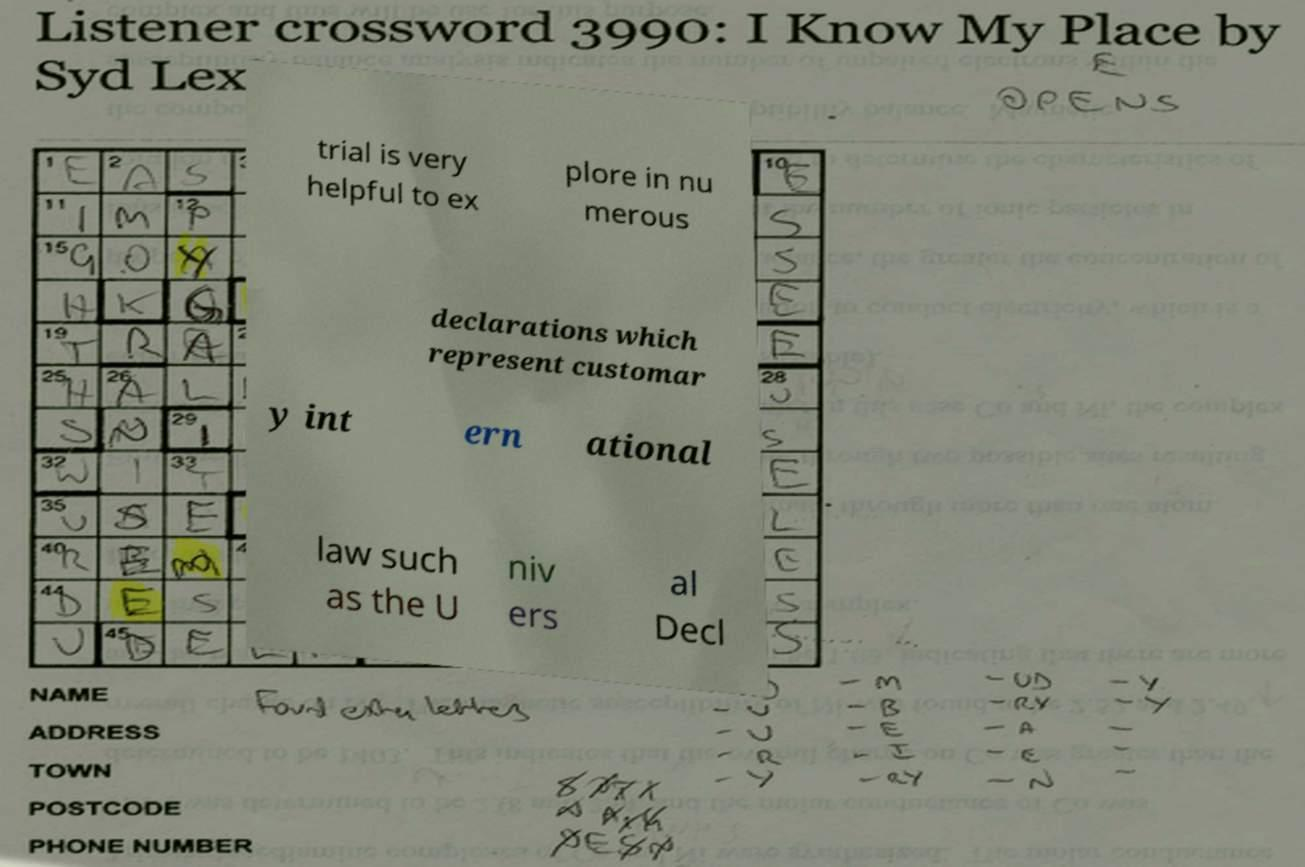Please read and relay the text visible in this image. What does it say? trial is very helpful to ex plore in nu merous declarations which represent customar y int ern ational law such as the U niv ers al Decl 